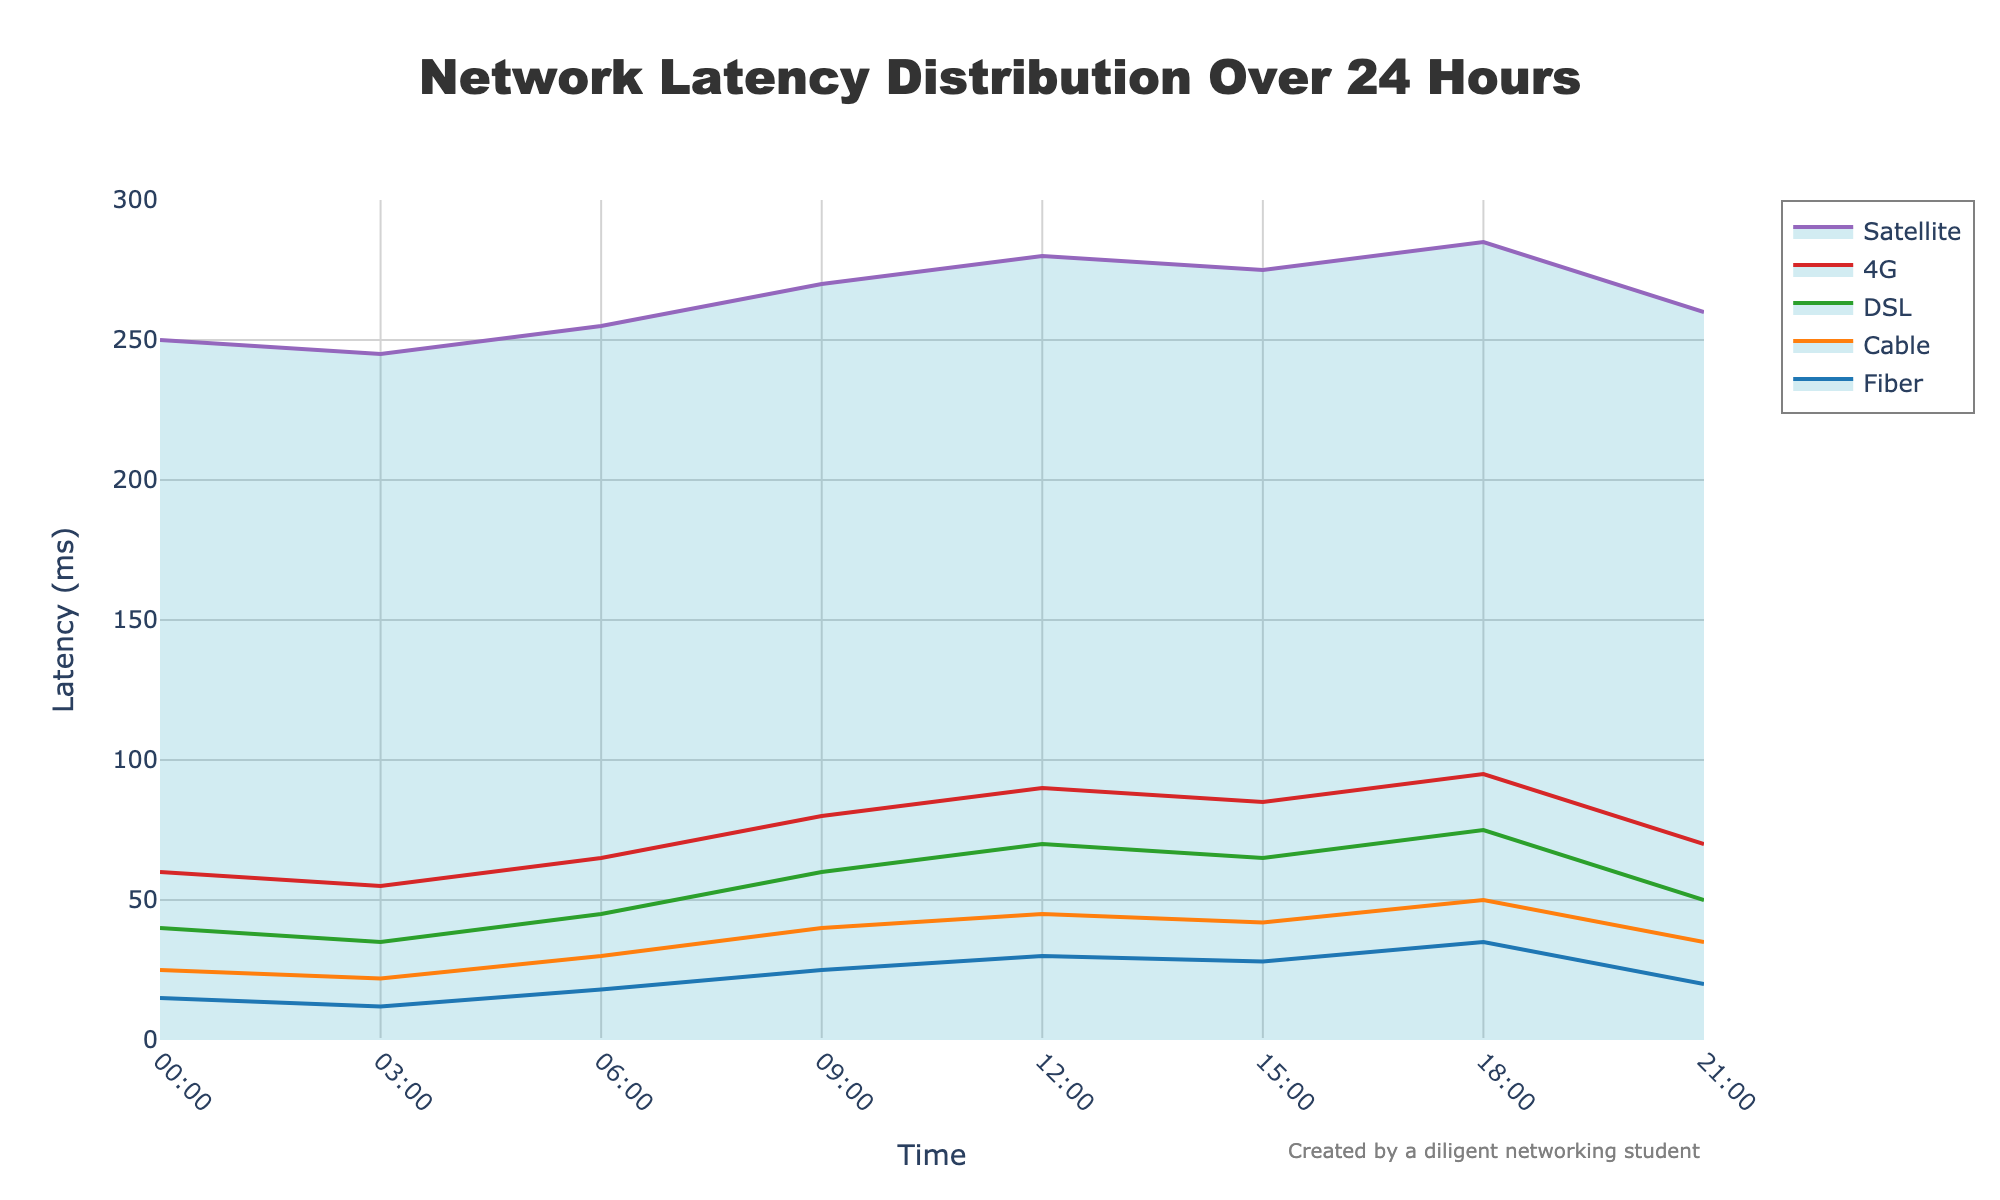What is the title of the figure? The title is usually positioned at the top of the figure. Here, it's mentioned as "Network Latency Distribution Over 24 Hours".
Answer: Network Latency Distribution Over 24 Hours Which connection type has the highest latency at 12:00? By looking at the 12:00 time point on the x-axis and then checking which connection type has the maximum y-axis value, it's evident that "Satellite" has the highest latency.
Answer: Satellite How does the latency of 4G change from 06:00 to 09:00? First, locate the latency values of 4G at 06:00 and 09:00, which are 65 ms and 80 ms respectively. The difference can be calculated as 80 - 65 = 15.
Answer: It increases by 15 ms At what time does Cable experience its highest latency? By scanning the plot for Cable (orange line), identify the peak point. Cable's highest latency is at 18:00 with 50 ms.
Answer: 18:00 What is the percentage decrease in latency for Fiber between 09:00 and 12:00? Fiber's latency at 09:00 is 25 ms, and at 12:00 it is 30 ms. The percentage decrease is calculated as: ((30 - 25) / 25) * 100 = 20%.
Answer: 20% Between which two time points does DSL experience the largest increase in latency? By observing DSL's latency line, the largest increase happens between 06:00 (45 ms) and 09:00 (60 ms), giving an increase of 15 ms.
Answer: Between 06:00 and 09:00 How does latency at 21:00 for Satellite compare to latency at 15:00 for Fiber? Satellite's latency at 21:00 is 260 ms, and Fiber's latency at 15:00 is 28 ms. Thus, 260 is significantly higher than 28.
Answer: Satellite has higher latency What is the average latency for Cable between 00:00 and 06:00? By averaging Cable's latencies at 00:00, 03:00, and 06:00: (25 + 22 + 30) / 3 = 25.67 ms.
Answer: 25.67 ms What is the trend in latency for Satellite from 00:00 to 21:00? Observing the Satellite line from left to right, it's clear that despite some fluctuations, the overall latency increases.
Answer: Increasing 